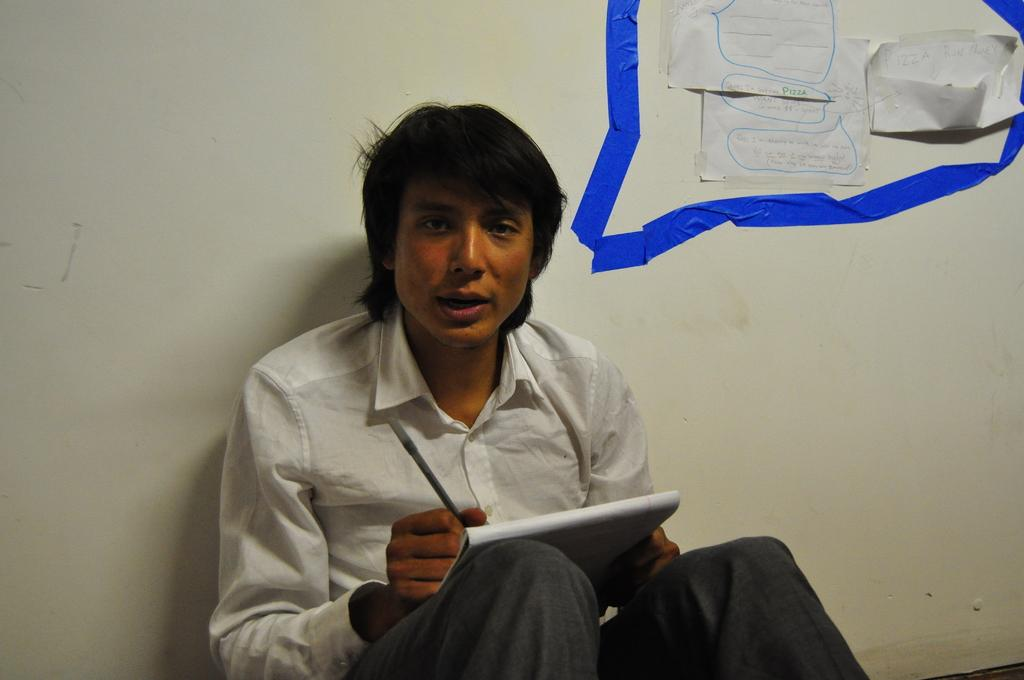What is the main subject of the image? There is a man in the image. What is the man doing in the image? The man is sitting in the image. What objects is the man holding in the image? The man is holding a book and a pen in the image. What can be seen behind the man in the image? There is a wall behind the man in the image. What is on the wall behind the man? There are posters on the wall behind the man in the image. How many sheep can be seen in the image? There are no sheep present in the image. What route does the man take to get to his destination in the image? The image does not provide information about the man's destination or the route he might take. 